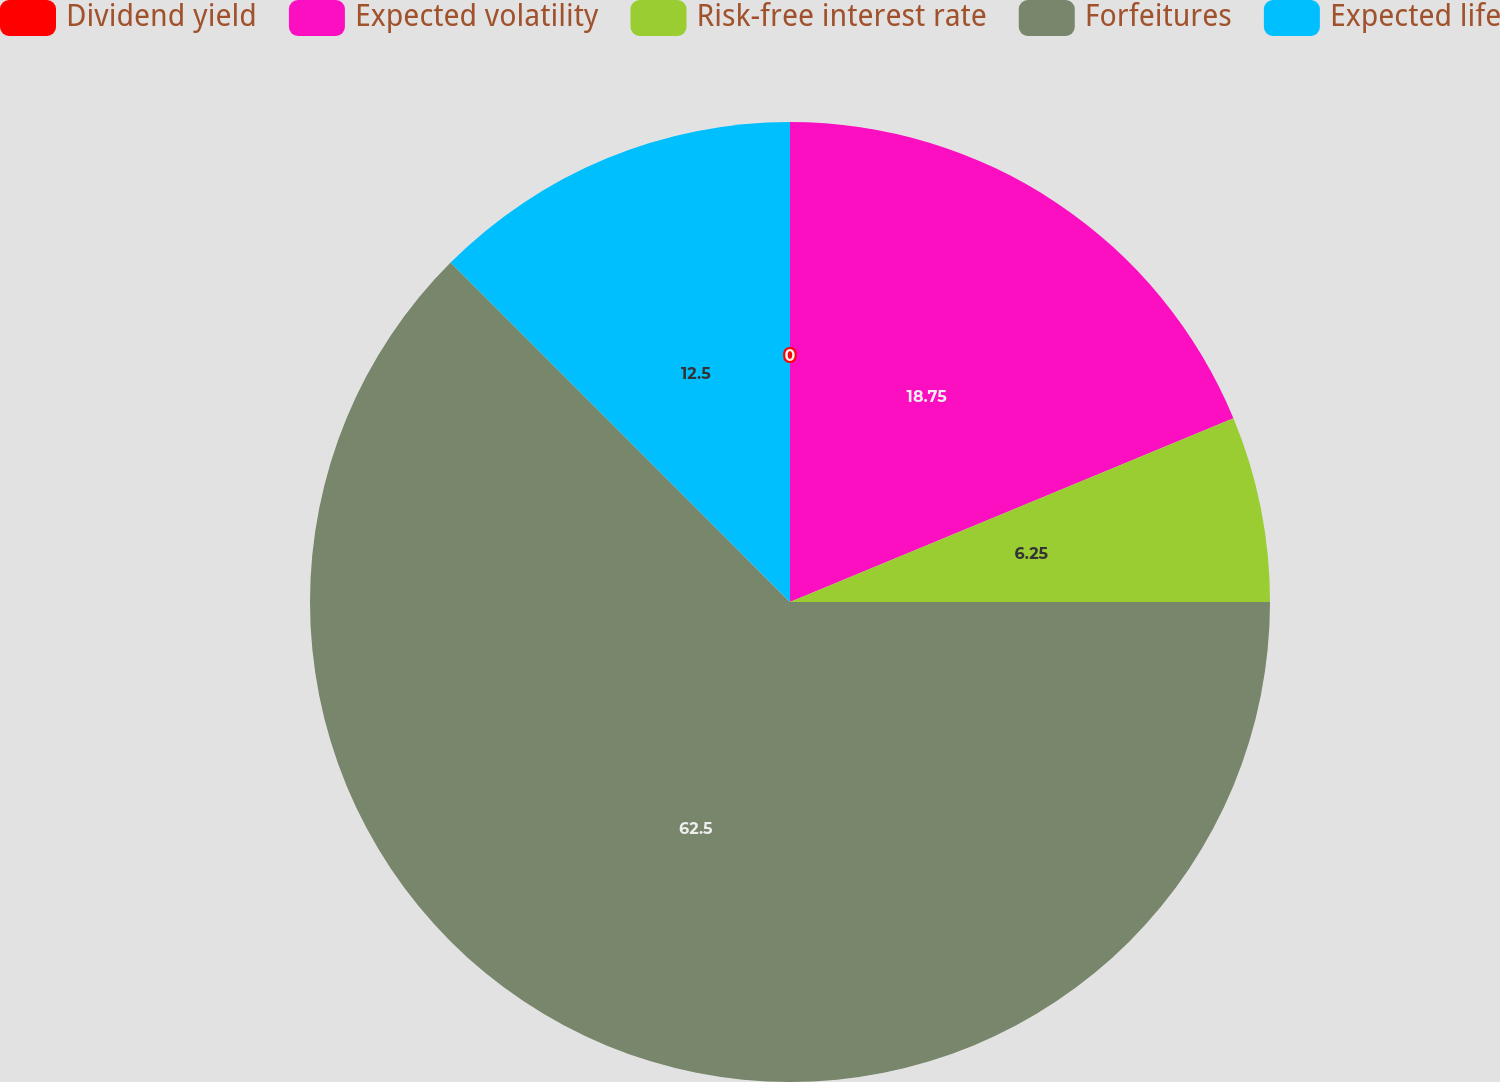<chart> <loc_0><loc_0><loc_500><loc_500><pie_chart><fcel>Dividend yield<fcel>Expected volatility<fcel>Risk-free interest rate<fcel>Forfeitures<fcel>Expected life<nl><fcel>0.0%<fcel>18.75%<fcel>6.25%<fcel>62.5%<fcel>12.5%<nl></chart> 